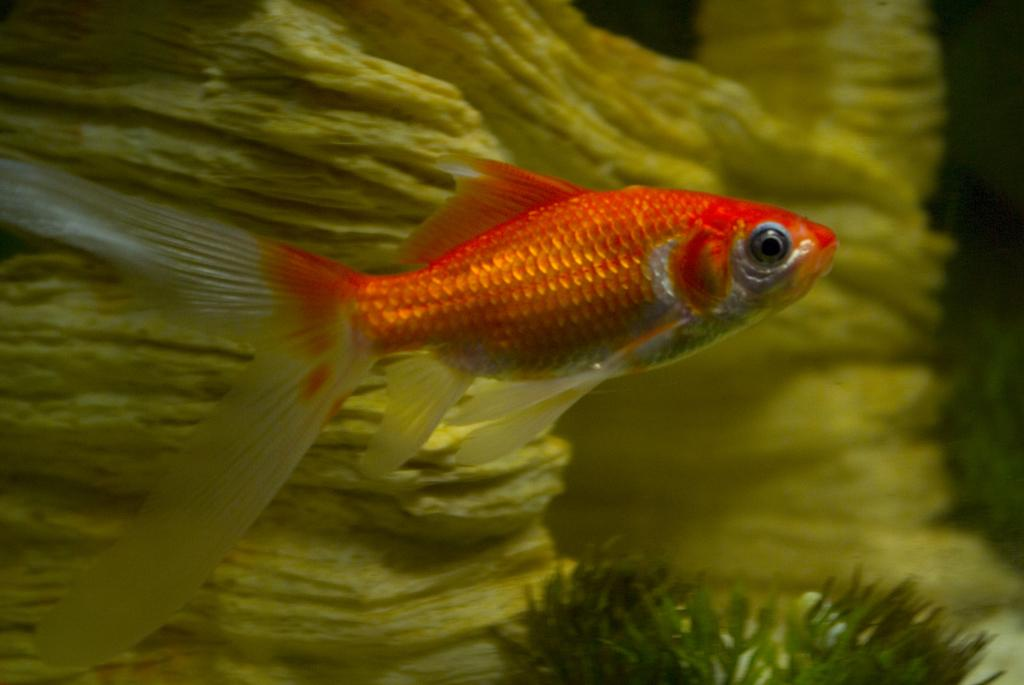What is the primary element in the image? There is water in the image. What can be seen swimming in the water? There is a fish in the water. What type of vegetation is present at the bottom of the image? There is grass at the bottom of the image. What object is located behind the fish? There is a stone behind the fish. How does the fish obtain approval from the plant in the image? There is no plant present in the image, and therefore no approval-seeking behavior can be observed. 